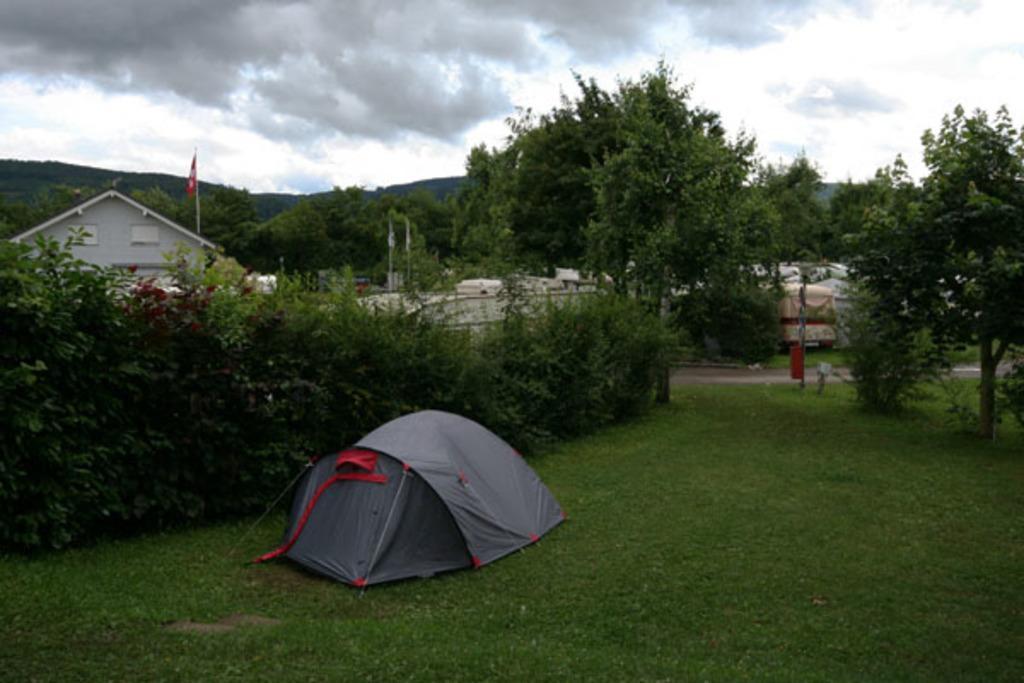In one or two sentences, can you explain what this image depicts? In this picture I can see there are plants, grass, building, road and in the backdrop there are trees and the sky is clear. 